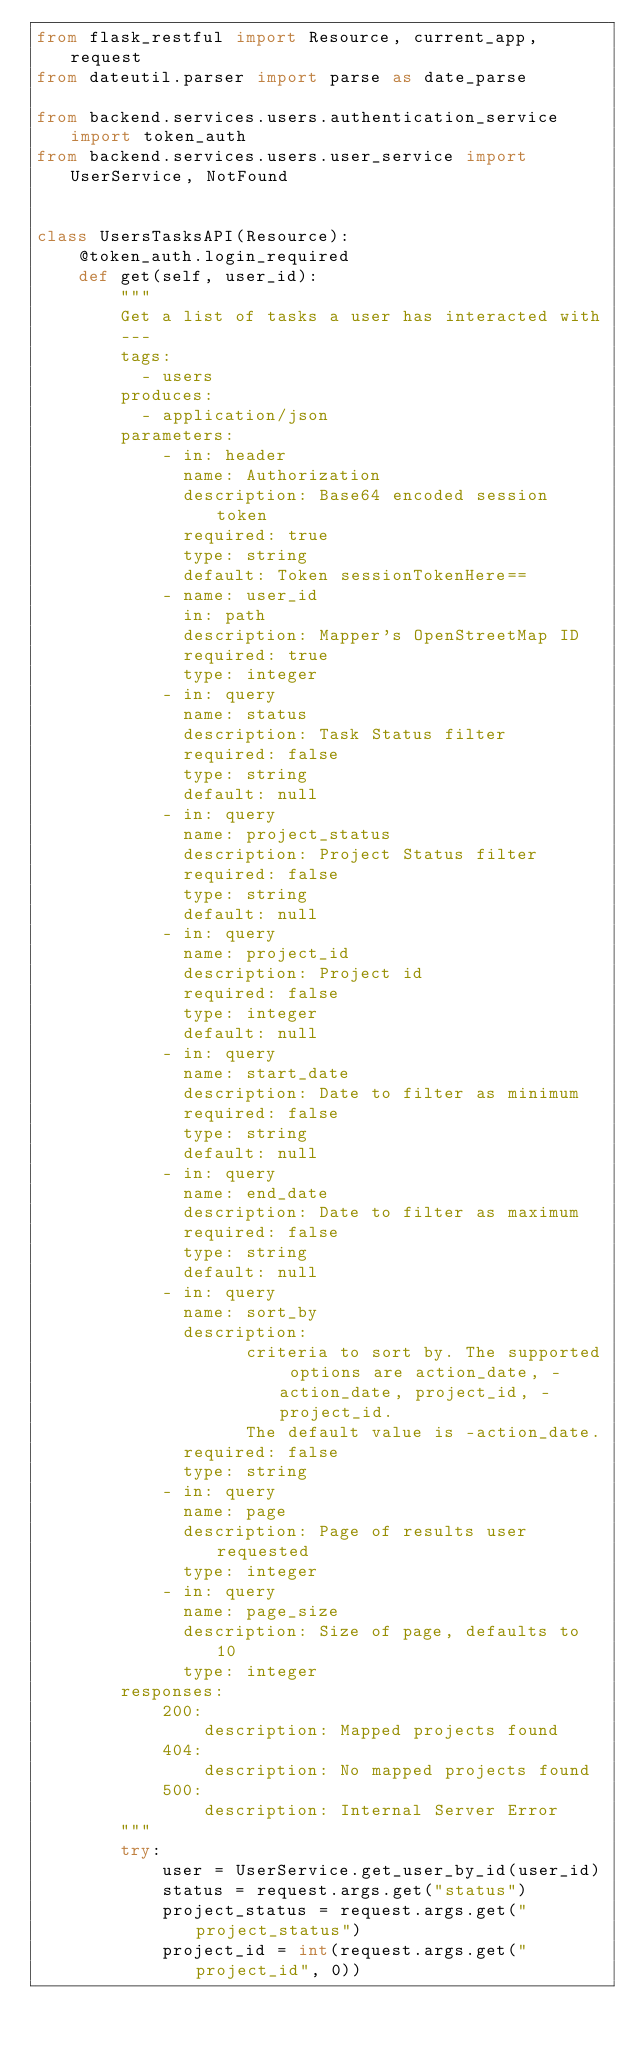Convert code to text. <code><loc_0><loc_0><loc_500><loc_500><_Python_>from flask_restful import Resource, current_app, request
from dateutil.parser import parse as date_parse

from backend.services.users.authentication_service import token_auth
from backend.services.users.user_service import UserService, NotFound


class UsersTasksAPI(Resource):
    @token_auth.login_required
    def get(self, user_id):
        """
        Get a list of tasks a user has interacted with
        ---
        tags:
          - users
        produces:
          - application/json
        parameters:
            - in: header
              name: Authorization
              description: Base64 encoded session token
              required: true
              type: string
              default: Token sessionTokenHere==
            - name: user_id
              in: path
              description: Mapper's OpenStreetMap ID
              required: true
              type: integer
            - in: query
              name: status
              description: Task Status filter
              required: false
              type: string
              default: null
            - in: query
              name: project_status
              description: Project Status filter
              required: false
              type: string
              default: null
            - in: query
              name: project_id
              description: Project id
              required: false
              type: integer
              default: null
            - in: query
              name: start_date
              description: Date to filter as minimum
              required: false
              type: string
              default: null
            - in: query
              name: end_date
              description: Date to filter as maximum
              required: false
              type: string
              default: null
            - in: query
              name: sort_by
              description:
                    criteria to sort by. The supported options are action_date, -action_date, project_id, -project_id.
                    The default value is -action_date.
              required: false
              type: string
            - in: query
              name: page
              description: Page of results user requested
              type: integer
            - in: query
              name: page_size
              description: Size of page, defaults to 10
              type: integer
        responses:
            200:
                description: Mapped projects found
            404:
                description: No mapped projects found
            500:
                description: Internal Server Error
        """
        try:
            user = UserService.get_user_by_id(user_id)
            status = request.args.get("status")
            project_status = request.args.get("project_status")
            project_id = int(request.args.get("project_id", 0))</code> 